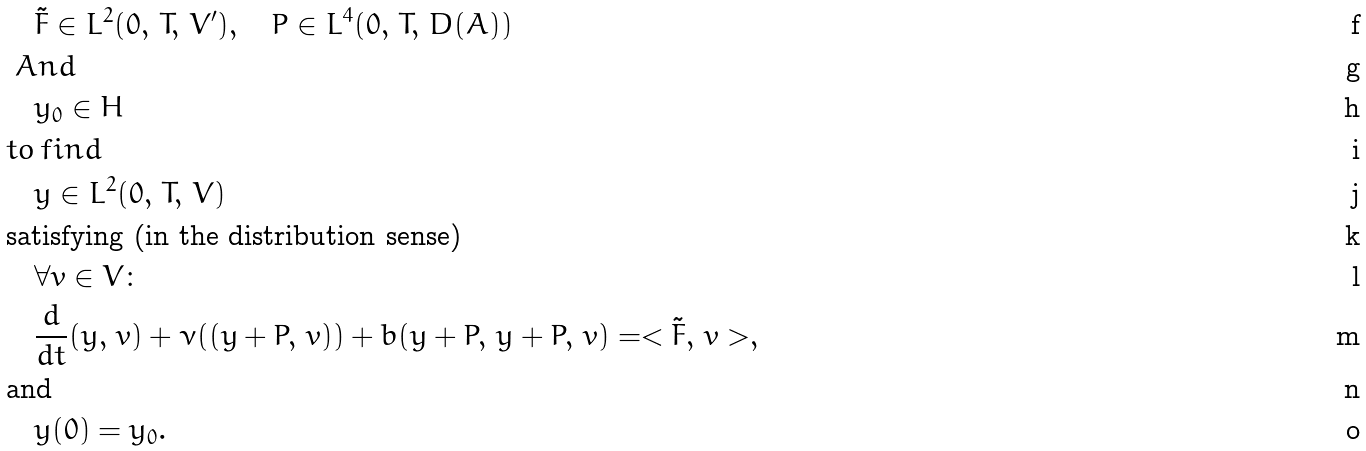<formula> <loc_0><loc_0><loc_500><loc_500>& \quad \tilde { F } \in L ^ { 2 } ( 0 , \, T , \, V ^ { \prime } ) , \quad P \in L ^ { 4 } ( 0 , \, T , \, D ( A ) ) \\ & \ A n d \\ & \quad y _ { 0 } \in H \\ & t o \, f i n d \\ & \quad y \in L ^ { 2 } ( 0 , \, T , \, V ) \\ & \text {satisfying (in the distribution sense)} \\ & \quad \forall v \in V \colon \\ & \quad \frac { d } { d t } ( y , \, v ) + \nu ( ( y + P , \, v ) ) + b ( y + P , \, y + P , \, v ) = < \tilde { F } , \, v > , \\ & \text {and} \\ & \quad y ( 0 ) = y _ { 0 } .</formula> 